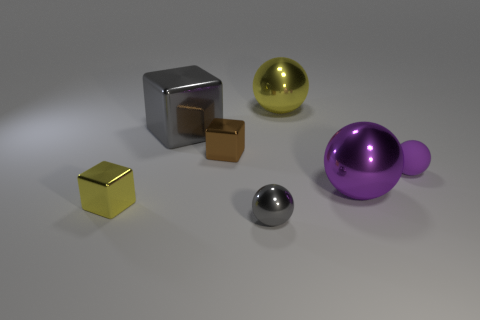There is a thing that is the same color as the rubber sphere; what is its material?
Provide a short and direct response. Metal. What shape is the purple rubber thing that is the same size as the brown thing?
Keep it short and to the point. Sphere. There is a cube that is in front of the large purple ball; what color is it?
Provide a succinct answer. Yellow. Is there a large purple thing that is behind the large shiny thing that is on the left side of the small gray metallic sphere?
Offer a very short reply. No. How many things are gray things behind the small gray shiny sphere or red rubber cylinders?
Your answer should be compact. 1. Are there any other things that have the same size as the matte thing?
Offer a terse response. Yes. The tiny block to the left of the large thing on the left side of the brown metallic block is made of what material?
Offer a very short reply. Metal. Is the number of gray things that are in front of the yellow block the same as the number of big purple metallic things that are to the left of the tiny brown object?
Keep it short and to the point. No. How many things are either big shiny things on the right side of the big yellow sphere or shiny objects behind the small yellow thing?
Your response must be concise. 4. What is the sphere that is in front of the brown block and behind the purple shiny ball made of?
Provide a short and direct response. Rubber. 